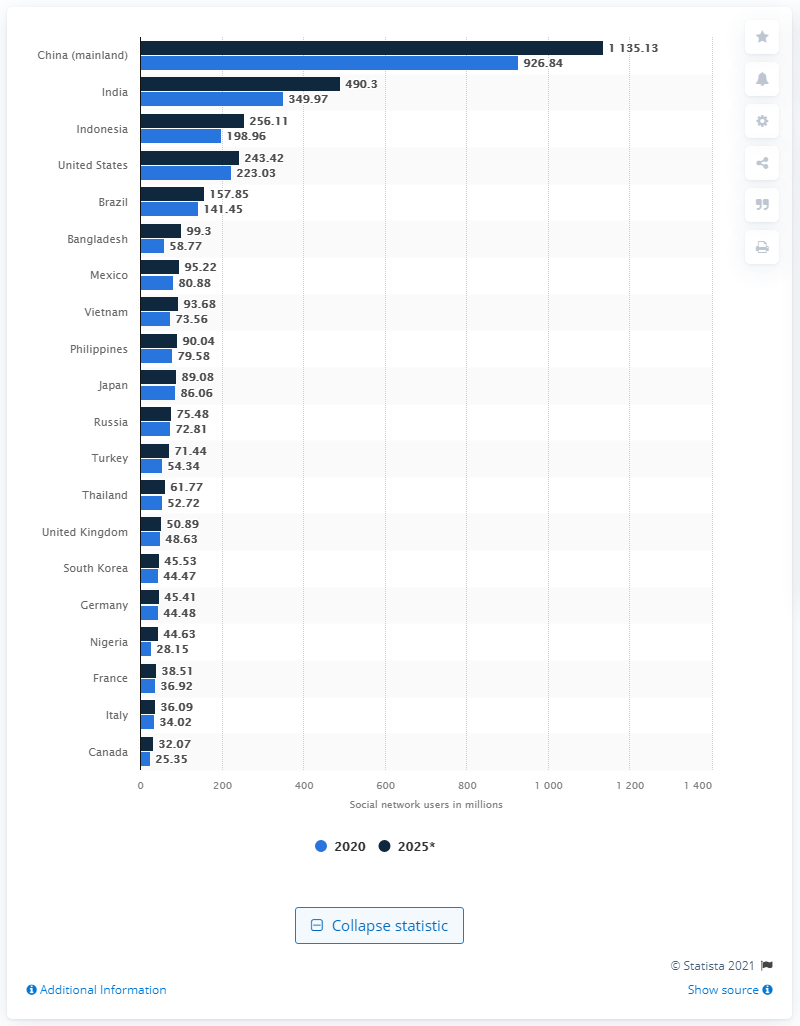Outline some significant characteristics in this image. There were 926.84 million Chinese internet users in 2020. According to recent data, approximately 349.97 people in China use social media. 